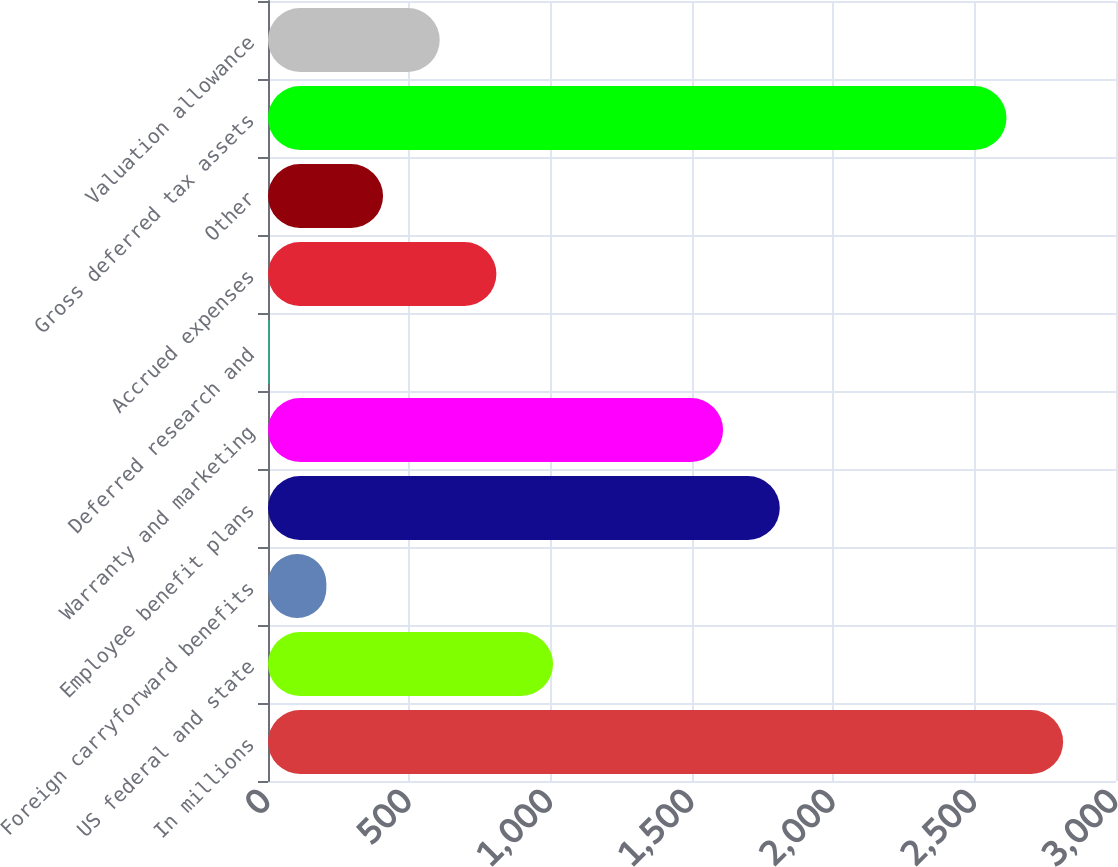Convert chart to OTSL. <chart><loc_0><loc_0><loc_500><loc_500><bar_chart><fcel>In millions<fcel>US federal and state<fcel>Foreign carryforward benefits<fcel>Employee benefit plans<fcel>Warranty and marketing<fcel>Deferred research and<fcel>Accrued expenses<fcel>Other<fcel>Gross deferred tax assets<fcel>Valuation allowance<nl><fcel>2813<fcel>1008.5<fcel>206.5<fcel>1810.5<fcel>1610<fcel>6<fcel>808<fcel>407<fcel>2612.5<fcel>607.5<nl></chart> 